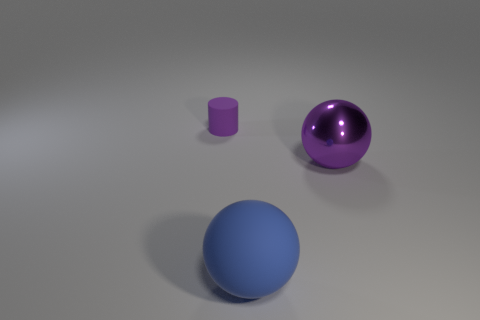Is there any other thing that has the same material as the purple sphere?
Your answer should be very brief. No. Is the number of tiny purple rubber cylinders that are behind the purple cylinder less than the number of matte things that are on the right side of the big purple shiny thing?
Make the answer very short. No. The rubber object right of the purple thing that is to the left of the blue sphere is what shape?
Offer a terse response. Sphere. Is there any other thing of the same color as the cylinder?
Keep it short and to the point. Yes. Is the color of the small cylinder the same as the rubber sphere?
Offer a terse response. No. How many purple objects are either matte cylinders or big metal things?
Your response must be concise. 2. Are there fewer purple matte cylinders that are in front of the large matte object than purple things?
Give a very brief answer. Yes. There is a ball behind the blue sphere; what number of tiny purple objects are left of it?
Your answer should be compact. 1. How many other objects are the same size as the shiny sphere?
Your response must be concise. 1. How many objects are big shiny balls or blue rubber balls on the left side of the purple metal object?
Your answer should be very brief. 2. 